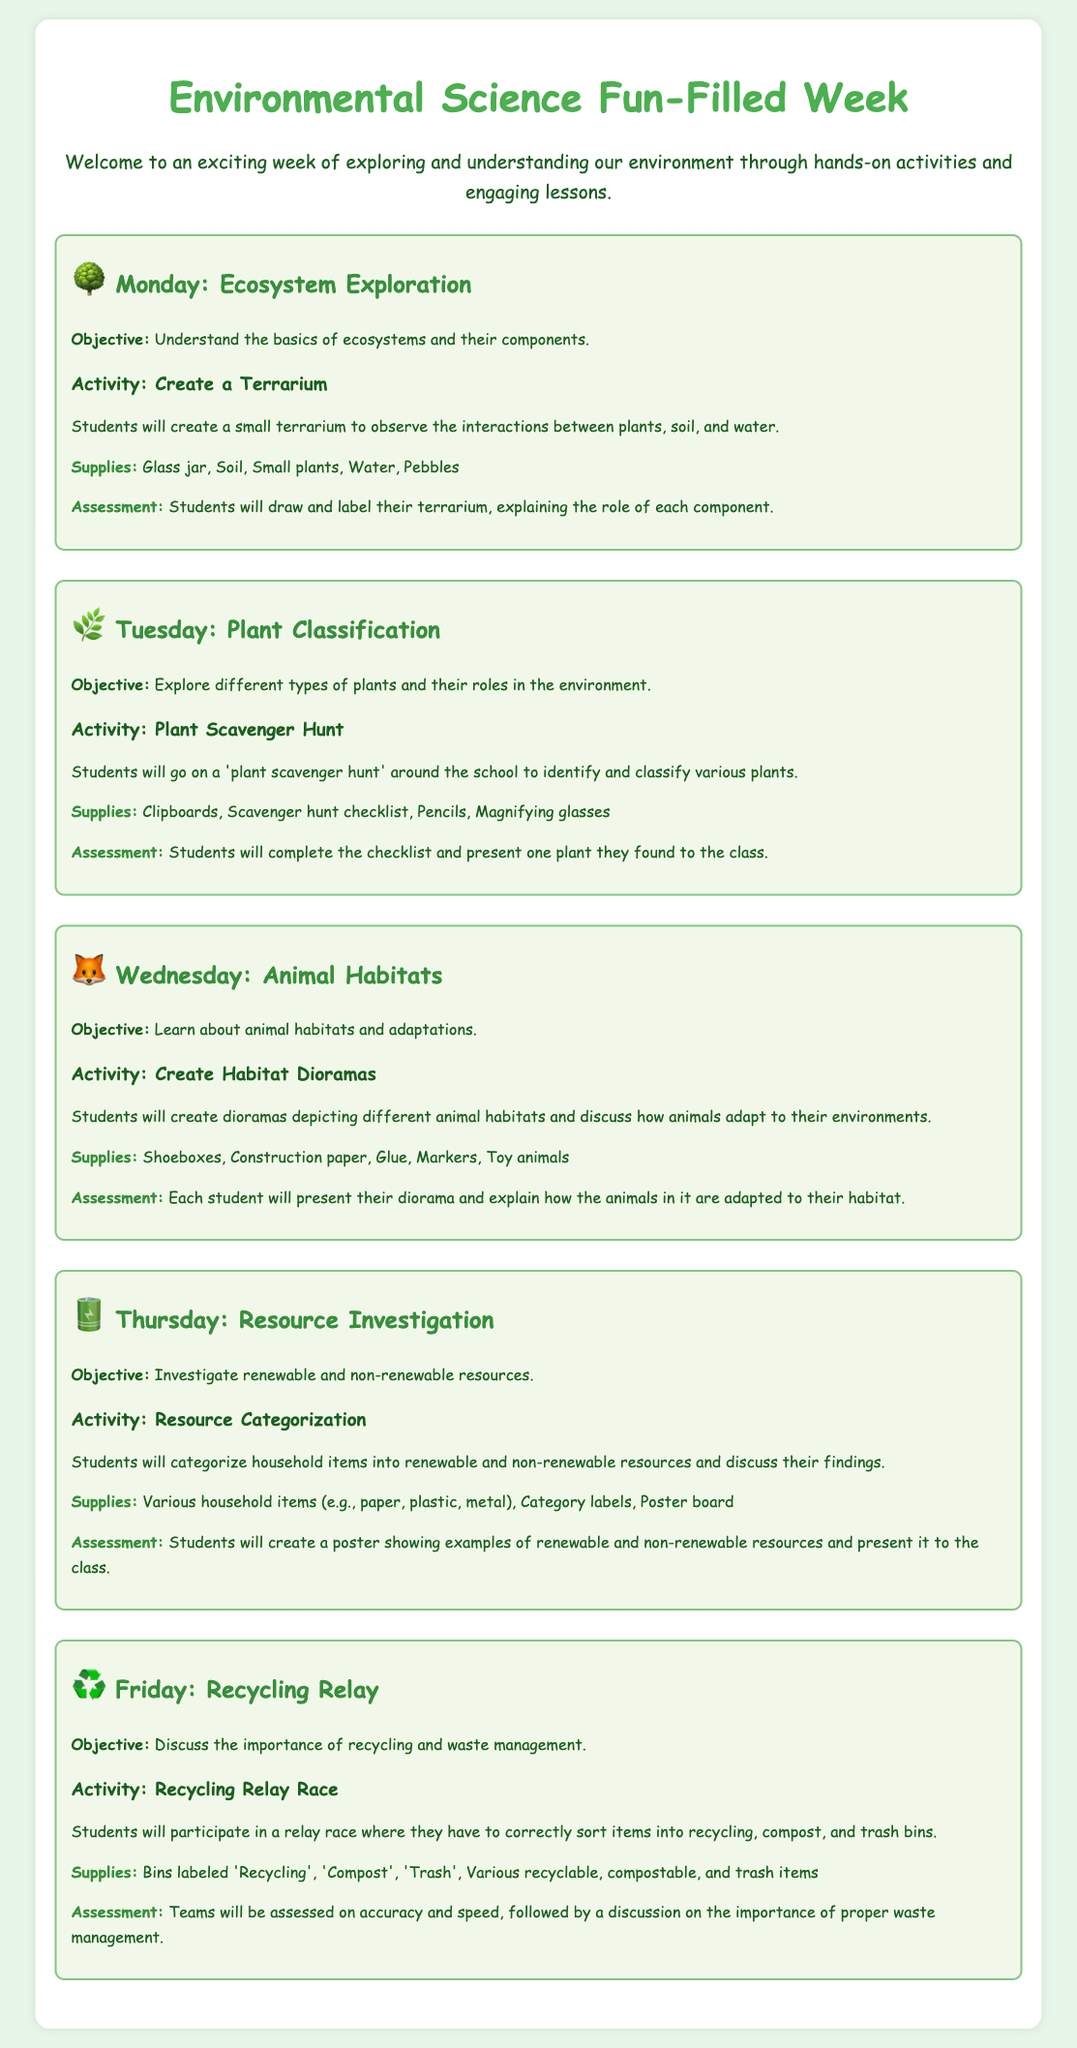What is the title of the document? The title is prominently displayed at the top of the document, introducing the theme of the week's activities.
Answer: Environmental Science Fun-Filled Week What is the objective for Tuesday? The objective is clearly stated under the Tuesday section, outlining the focus of the day's activities.
Answer: Explore different types of plants and their roles in the environment How many activities are included on Wednesday? By reviewing the Wednesday section, we find there is one activity mentioned for that day.
Answer: 1 What are the supplies needed for Thursday's activity? The supplies are listed specifically under the Thursday section, detailing what is required for the activity.
Answer: Various household items (e.g., paper, plastic, metal), Category labels, Poster board What is the assessment method for Friday? The assessment is explained in the Friday section, highlighting how students will be evaluated.
Answer: Teams will be assessed on accuracy and speed, followed by a discussion on the importance of proper waste management What icon represents Monday's theme? The document uses icons to visually represent each day's theme, with the specific icon for Monday noted in the heading.
Answer: 🌳 What is the main focus of the activity on Tuesday? The activity's focus can be found in the description provided beneath Tuesday's title.
Answer: Plant Scavenger Hunt How are students assessed on their terrarium project? The assessment method is described after the activity under Monday, explaining students' evaluation for that project.
Answer: Students will draw and label their terrarium, explaining the role of each component 